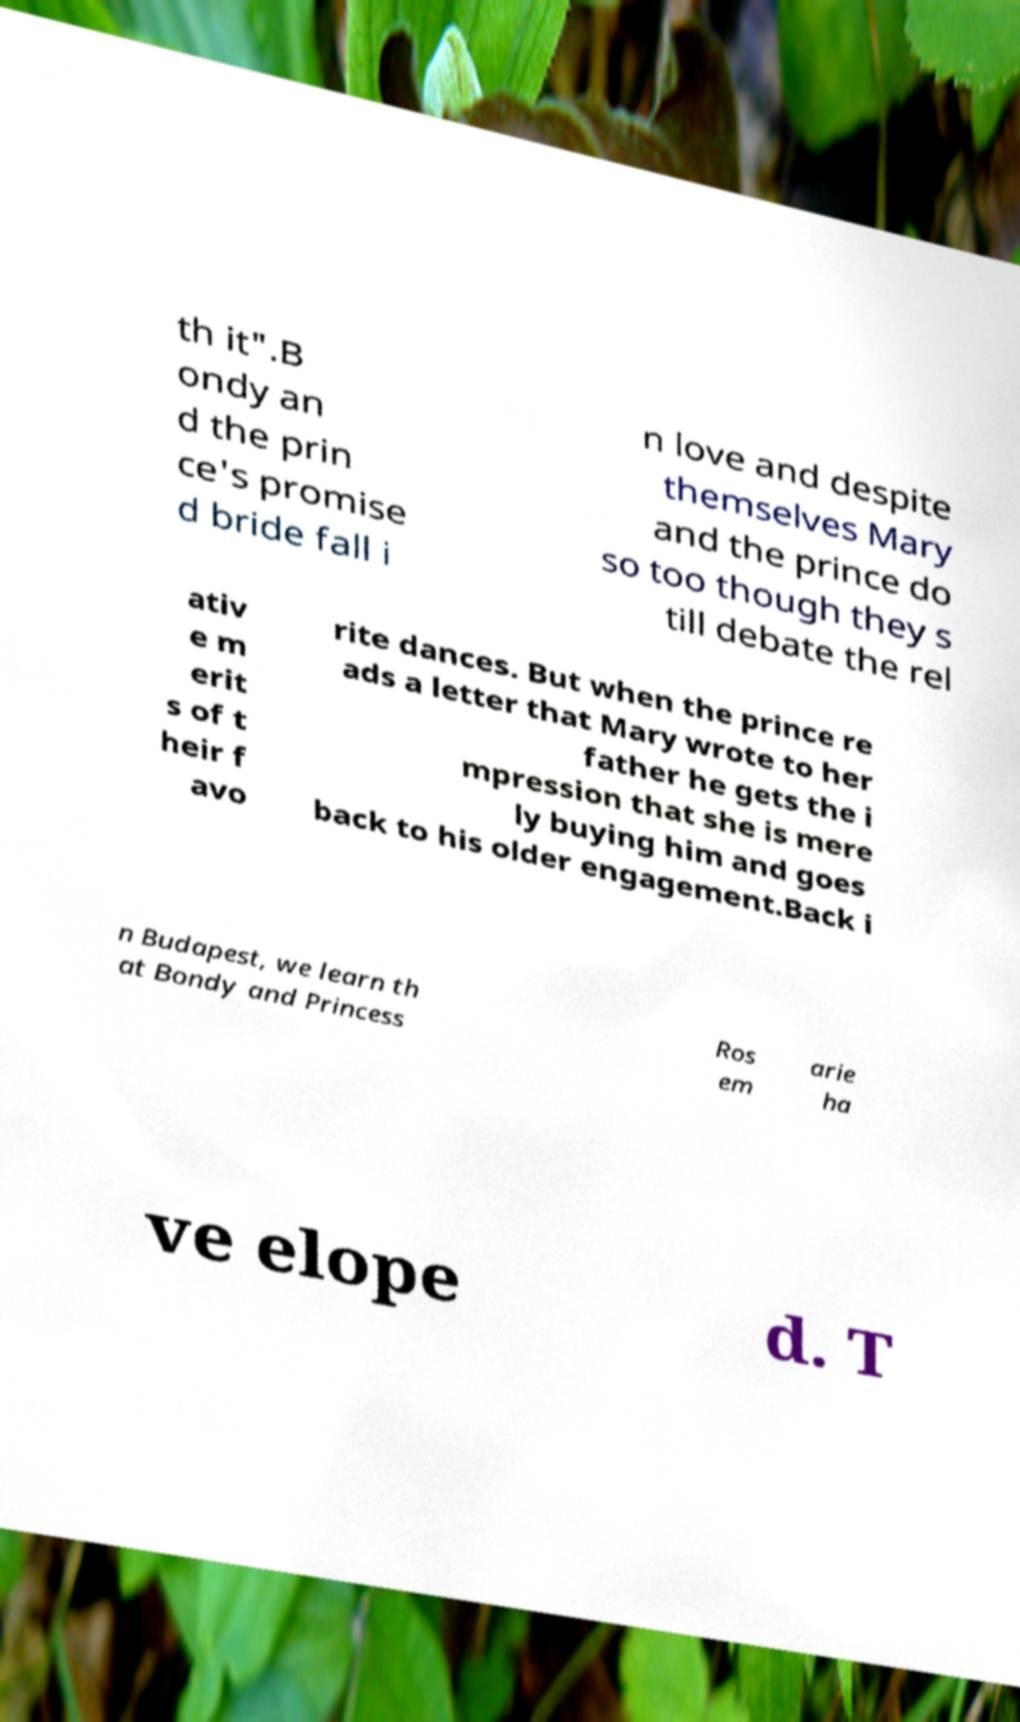Please read and relay the text visible in this image. What does it say? th it".B ondy an d the prin ce's promise d bride fall i n love and despite themselves Mary and the prince do so too though they s till debate the rel ativ e m erit s of t heir f avo rite dances. But when the prince re ads a letter that Mary wrote to her father he gets the i mpression that she is mere ly buying him and goes back to his older engagement.Back i n Budapest, we learn th at Bondy and Princess Ros em arie ha ve elope d. T 